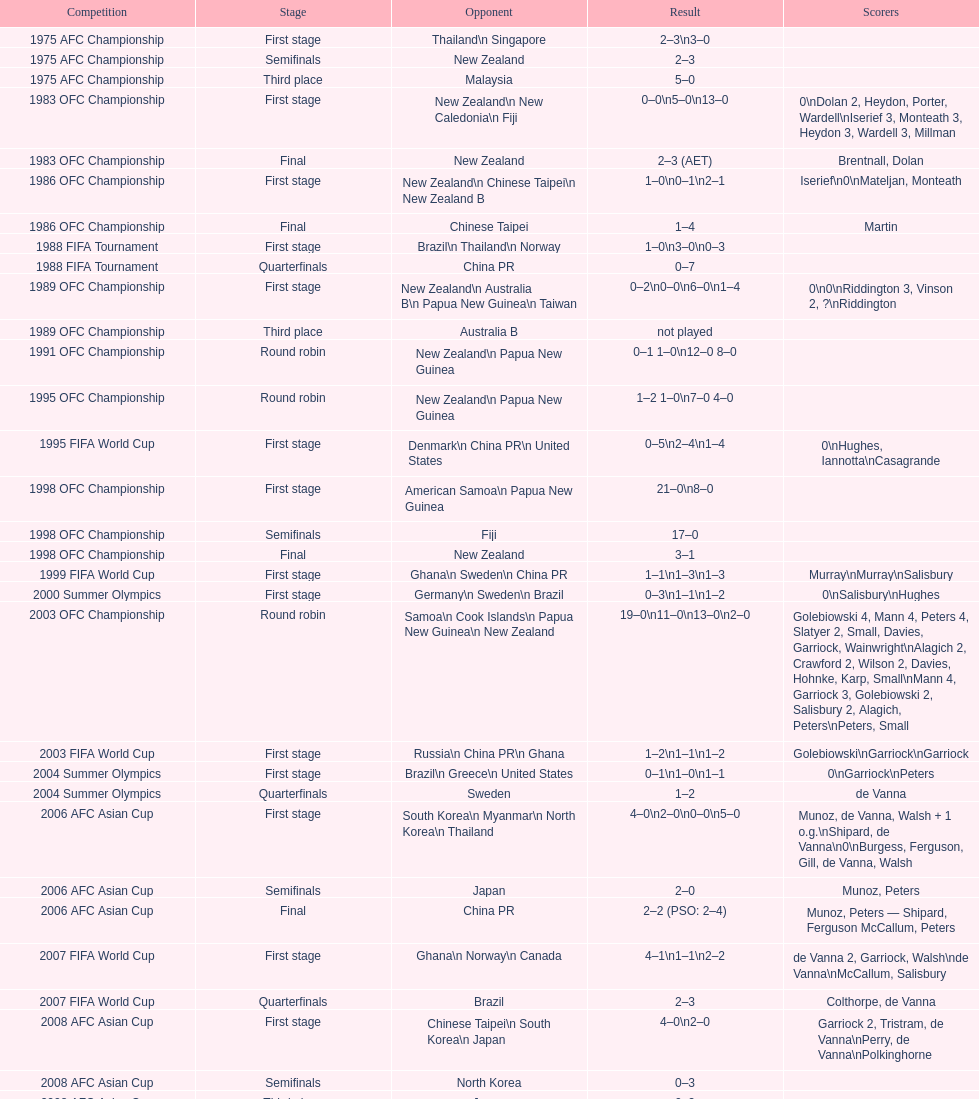Who was the last opponent this team faced in the 2010 afc asian cup? North Korea. 